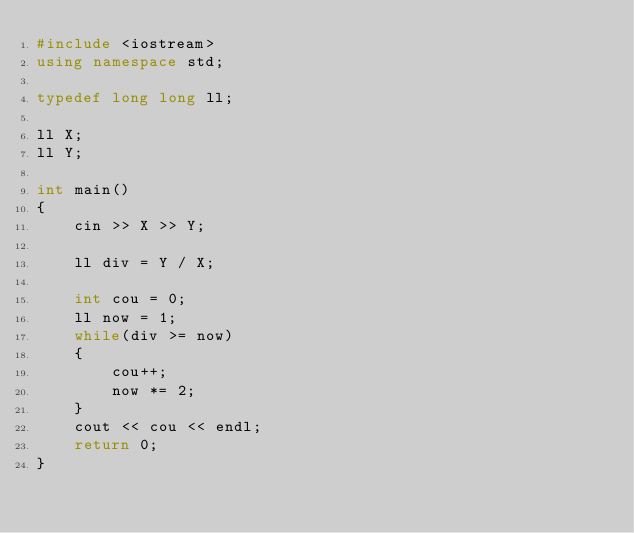Convert code to text. <code><loc_0><loc_0><loc_500><loc_500><_C++_>#include <iostream>
using namespace std;

typedef long long ll;

ll X;
ll Y;

int main()
{
	cin >> X >> Y;

	ll div = Y / X;

	int cou = 0;
	ll now = 1;
	while(div >= now)
	{
		cou++;
		now *= 2;
	}
	cout << cou << endl;
	return 0;
}
</code> 